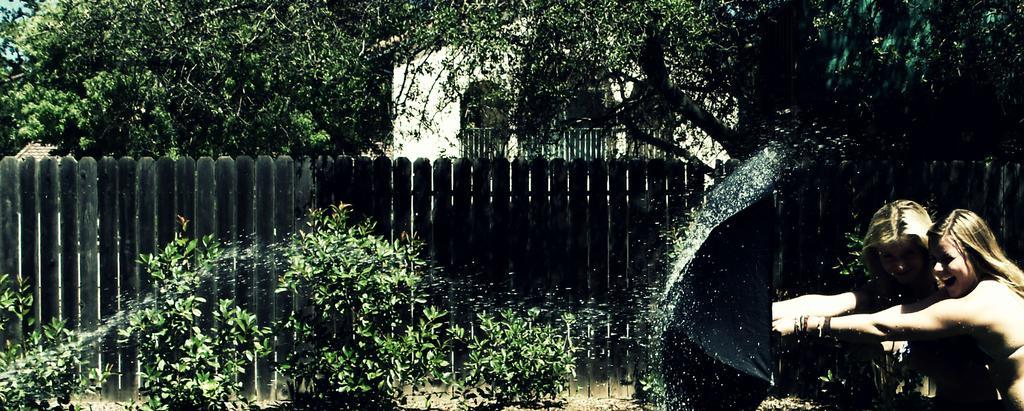How would you summarize this image in a sentence or two? In the background we can see the wall and the fence. In this picture we can see the trees, wooden fence, plants. On the right side of the picture we can see the women and they are smiling. It seems like an umbrella which is in black color. 